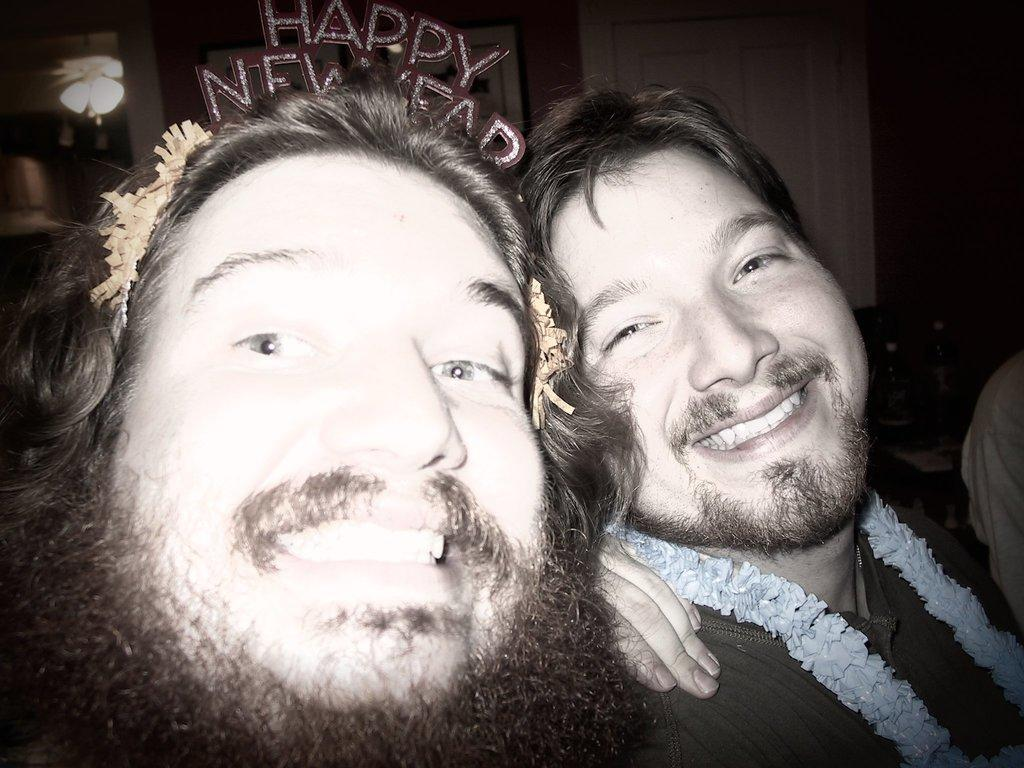How many people are in the image? There is a group of people in the image. Can you describe any specific clothing or accessories worn by someone in the image? One person is wearing a garland around their neck. What can be seen in the background of the image? There are bottles, a window, and photo frames in the background of the image. What type of print can be seen on the visitor's shirt in the image? There is no visitor present in the image, and therefore no shirt or print can be observed. 